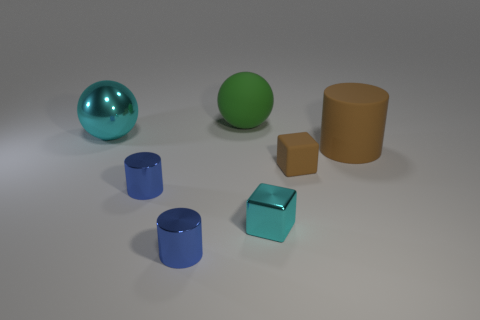What number of cyan blocks are on the left side of the big cyan object?
Give a very brief answer. 0. There is a shiny cube in front of the big rubber thing that is behind the big cyan shiny thing; is there a large object right of it?
Your response must be concise. Yes. How many cyan spheres are the same size as the matte cylinder?
Your answer should be very brief. 1. The big sphere behind the cyan ball behind the tiny metal block is made of what material?
Offer a very short reply. Rubber. What is the shape of the rubber object that is left of the tiny block that is to the left of the matte thing that is in front of the large brown rubber cylinder?
Give a very brief answer. Sphere. There is a cyan thing that is in front of the big matte cylinder; is it the same shape as the matte thing that is behind the brown cylinder?
Your response must be concise. No. What number of other things are made of the same material as the brown cube?
Provide a succinct answer. 2. What shape is the large brown object that is the same material as the tiny brown cube?
Provide a short and direct response. Cylinder. Is the size of the brown matte cylinder the same as the metallic ball?
Ensure brevity in your answer.  Yes. There is a metallic thing to the right of the big sphere behind the big metallic object; how big is it?
Provide a short and direct response. Small. 